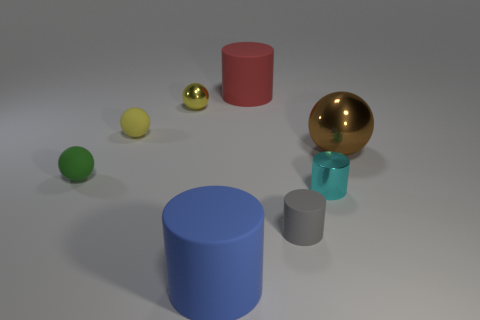Subtract all large balls. How many balls are left? 3 Subtract all gray cylinders. How many cylinders are left? 3 Add 2 big blue rubber things. How many objects exist? 10 Subtract 1 brown balls. How many objects are left? 7 Subtract 3 balls. How many balls are left? 1 Subtract all purple cylinders. Subtract all red spheres. How many cylinders are left? 4 Subtract all purple balls. How many gray cylinders are left? 1 Subtract all small gray matte things. Subtract all matte objects. How many objects are left? 2 Add 7 red cylinders. How many red cylinders are left? 8 Add 7 small red objects. How many small red objects exist? 7 